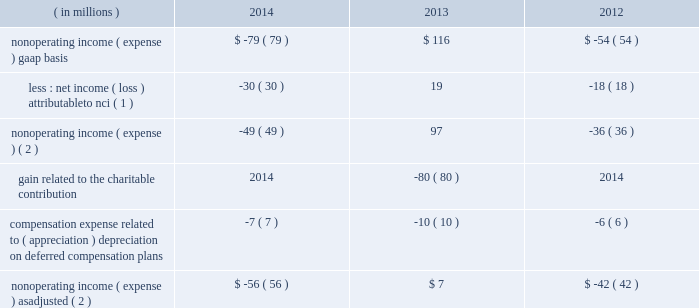Contribution incurred in 2013 and foreign currency remeasurement , partially offset by the $ 50 million reduction of an indemnification asset .
As adjusted .
Expense , as adjusted , increased $ 362 million , or 6% ( 6 % ) , to $ 6518 million in 2014 from $ 6156 million in 2013 .
The increase in total expense , as adjusted , is primarily attributable to higher employee compensation and benefits and direct fund expense .
Amounts related to the reduction of the indemnification asset and the charitable contribution have been excluded from as adjusted results .
2013 compared with 2012 gaap .
Expense increased $ 510 million , or 9% ( 9 % ) , from 2012 , primarily reflecting higher revenue-related expense and the $ 124 million expense related to the charitable contribution .
Employee compensation and benefits expense increased $ 273 million , or 8% ( 8 % ) , to $ 3560 million in 2013 from $ 3287 million in 2012 , reflecting higher headcount and higher incentive compensation driven by higher operating income , including higher performance fees .
Employees at december 31 , 2013 totaled approximately 11400 compared with approximately 10500 at december 31 , 2012 .
Distribution and servicing costs totaled $ 353 million in 2013 compared with $ 364 million in 2012 .
These costs included payments to bank of america/merrill lynch under a global distribution agreement and payments to pnc , as well as other third parties , primarily associated with the distribution and servicing of client investments in certain blackrock products .
Distribution and servicing costs for 2013 and 2012 included $ 184 million and $ 195 million , respectively , attributable to bank of america/merrill lynch .
Direct fund expense increased $ 66 million , reflecting higher average aum , primarily related to ishares , where blackrock pays certain nonadvisory expense of the funds .
General and administration expense increased $ 181 million , largely driven by the $ 124 million expense related to the charitable contribution , higher marketing and promotional costs and various lease exit costs .
The full year 2012 included a one-time $ 30 million contribution to stifs .
As adjusted .
Expense , as adjusted , increased $ 393 million , or 7% ( 7 % ) , to $ 6156 million in 2013 from $ 5763 million in 2012 .
The increase in total expense , as adjusted , is primarily attributable to higher employee compensation and benefits , direct fund expense and general and administration expense .
Nonoperating results nonoperating income ( expense ) , less net income ( loss ) attributable to nci for 2014 , 2013 and 2012 was as follows : ( in millions ) 2014 2013 2012 nonoperating income ( expense ) , gaap basis $ ( 79 ) $ 116 $ ( 54 ) less : net income ( loss ) attributable to nci ( 1 ) ( 30 ) 19 ( 18 ) nonoperating income ( expense ) ( 2 ) ( 49 ) 97 ( 36 ) gain related to the charitable contribution 2014 ( 80 ) 2014 compensation expense related to ( appreciation ) depreciation on deferred compensation plans ( 7 ) ( 10 ) ( 6 ) nonoperating income ( expense ) , as adjusted ( 2 ) $ ( 56 ) $ 7 $ ( 42 ) ( 1 ) amounts included losses of $ 41 million and $ 38 million attributable to consolidated variable interest entities ( 201cvies 201d ) for 2014 and 2012 , respectively .
During 2013 , the company did not record any nonoperating income ( loss ) or net income ( loss ) attributable to vies on the consolidated statements of income .
( 2 ) net of net income ( loss ) attributable to nci. .
Contribution incurred in 2013 and foreign currency remeasurement , partially offset by the $ 50 million reduction of an indemnification asset .
As adjusted .
Expense , as adjusted , increased $ 362 million , or 6% ( 6 % ) , to $ 6518 million in 2014 from $ 6156 million in 2013 .
The increase in total expense , as adjusted , is primarily attributable to higher employee compensation and benefits and direct fund expense .
Amounts related to the reduction of the indemnification asset and the charitable contribution have been excluded from as adjusted results .
2013 compared with 2012 gaap .
Expense increased $ 510 million , or 9% ( 9 % ) , from 2012 , primarily reflecting higher revenue-related expense and the $ 124 million expense related to the charitable contribution .
Employee compensation and benefits expense increased $ 273 million , or 8% ( 8 % ) , to $ 3560 million in 2013 from $ 3287 million in 2012 , reflecting higher headcount and higher incentive compensation driven by higher operating income , including higher performance fees .
Employees at december 31 , 2013 totaled approximately 11400 compared with approximately 10500 at december 31 , 2012 .
Distribution and servicing costs totaled $ 353 million in 2013 compared with $ 364 million in 2012 .
These costs included payments to bank of america/merrill lynch under a global distribution agreement and payments to pnc , as well as other third parties , primarily associated with the distribution and servicing of client investments in certain blackrock products .
Distribution and servicing costs for 2013 and 2012 included $ 184 million and $ 195 million , respectively , attributable to bank of america/merrill lynch .
Direct fund expense increased $ 66 million , reflecting higher average aum , primarily related to ishares , where blackrock pays certain nonadvisory expense of the funds .
General and administration expense increased $ 181 million , largely driven by the $ 124 million expense related to the charitable contribution , higher marketing and promotional costs and various lease exit costs .
The full year 2012 included a one-time $ 30 million contribution to stifs .
As adjusted .
Expense , as adjusted , increased $ 393 million , or 7% ( 7 % ) , to $ 6156 million in 2013 from $ 5763 million in 2012 .
The increase in total expense , as adjusted , is primarily attributable to higher employee compensation and benefits , direct fund expense and general and administration expense .
Nonoperating results nonoperating income ( expense ) , less net income ( loss ) attributable to nci for 2014 , 2013 and 2012 was as follows : ( in millions ) 2014 2013 2012 nonoperating income ( expense ) , gaap basis $ ( 79 ) $ 116 $ ( 54 ) less : net income ( loss ) attributable to nci ( 1 ) ( 30 ) 19 ( 18 ) nonoperating income ( expense ) ( 2 ) ( 49 ) 97 ( 36 ) gain related to the charitable contribution 2014 ( 80 ) 2014 compensation expense related to ( appreciation ) depreciation on deferred compensation plans ( 7 ) ( 10 ) ( 6 ) nonoperating income ( expense ) , as adjusted ( 2 ) $ ( 56 ) $ 7 $ ( 42 ) ( 1 ) amounts included losses of $ 41 million and $ 38 million attributable to consolidated variable interest entities ( 201cvies 201d ) for 2014 and 2012 , respectively .
During 2013 , the company did not record any nonoperating income ( loss ) or net income ( loss ) attributable to vies on the consolidated statements of income .
( 2 ) net of net income ( loss ) attributable to nci. .
What is the growth rate in employee headcount from 2012 to 2013? 
Computations: ((11400 - 10500) / 10500)
Answer: 0.08571. 